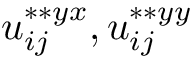<formula> <loc_0><loc_0><loc_500><loc_500>u _ { i j } ^ { \ast \ast { y x } } , u _ { i j } ^ { \ast \ast { y y } }</formula> 